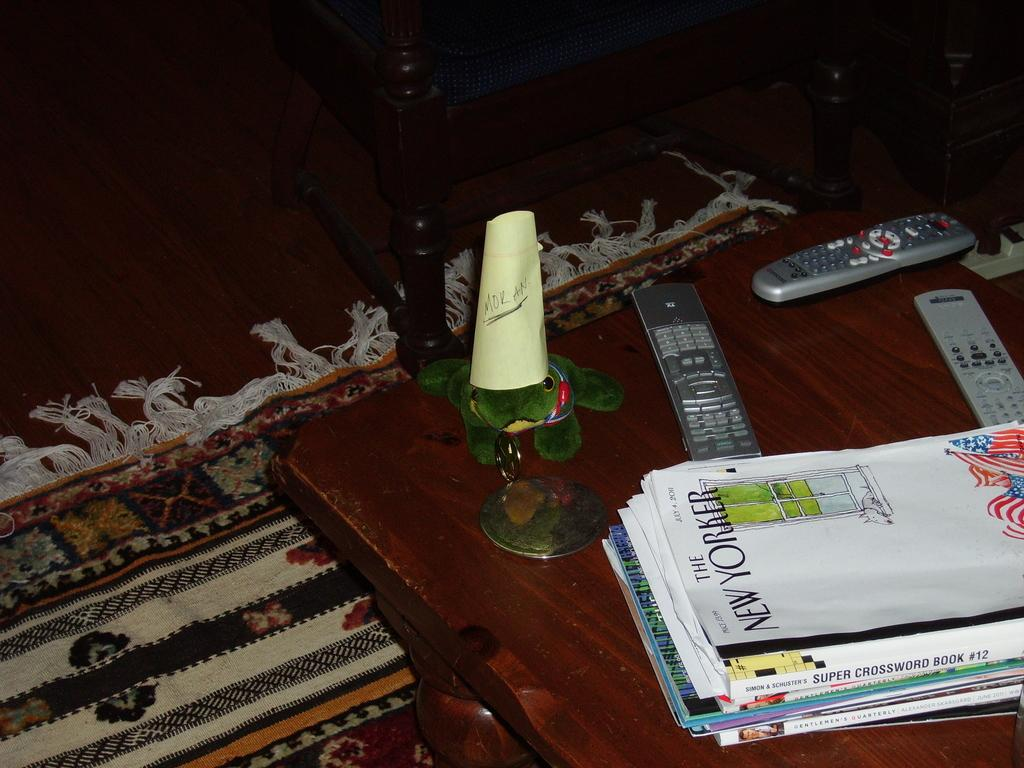Provide a one-sentence caption for the provided image. A small metal stand with a yellow paper that says Mor An underlined standing on a coffee table. 